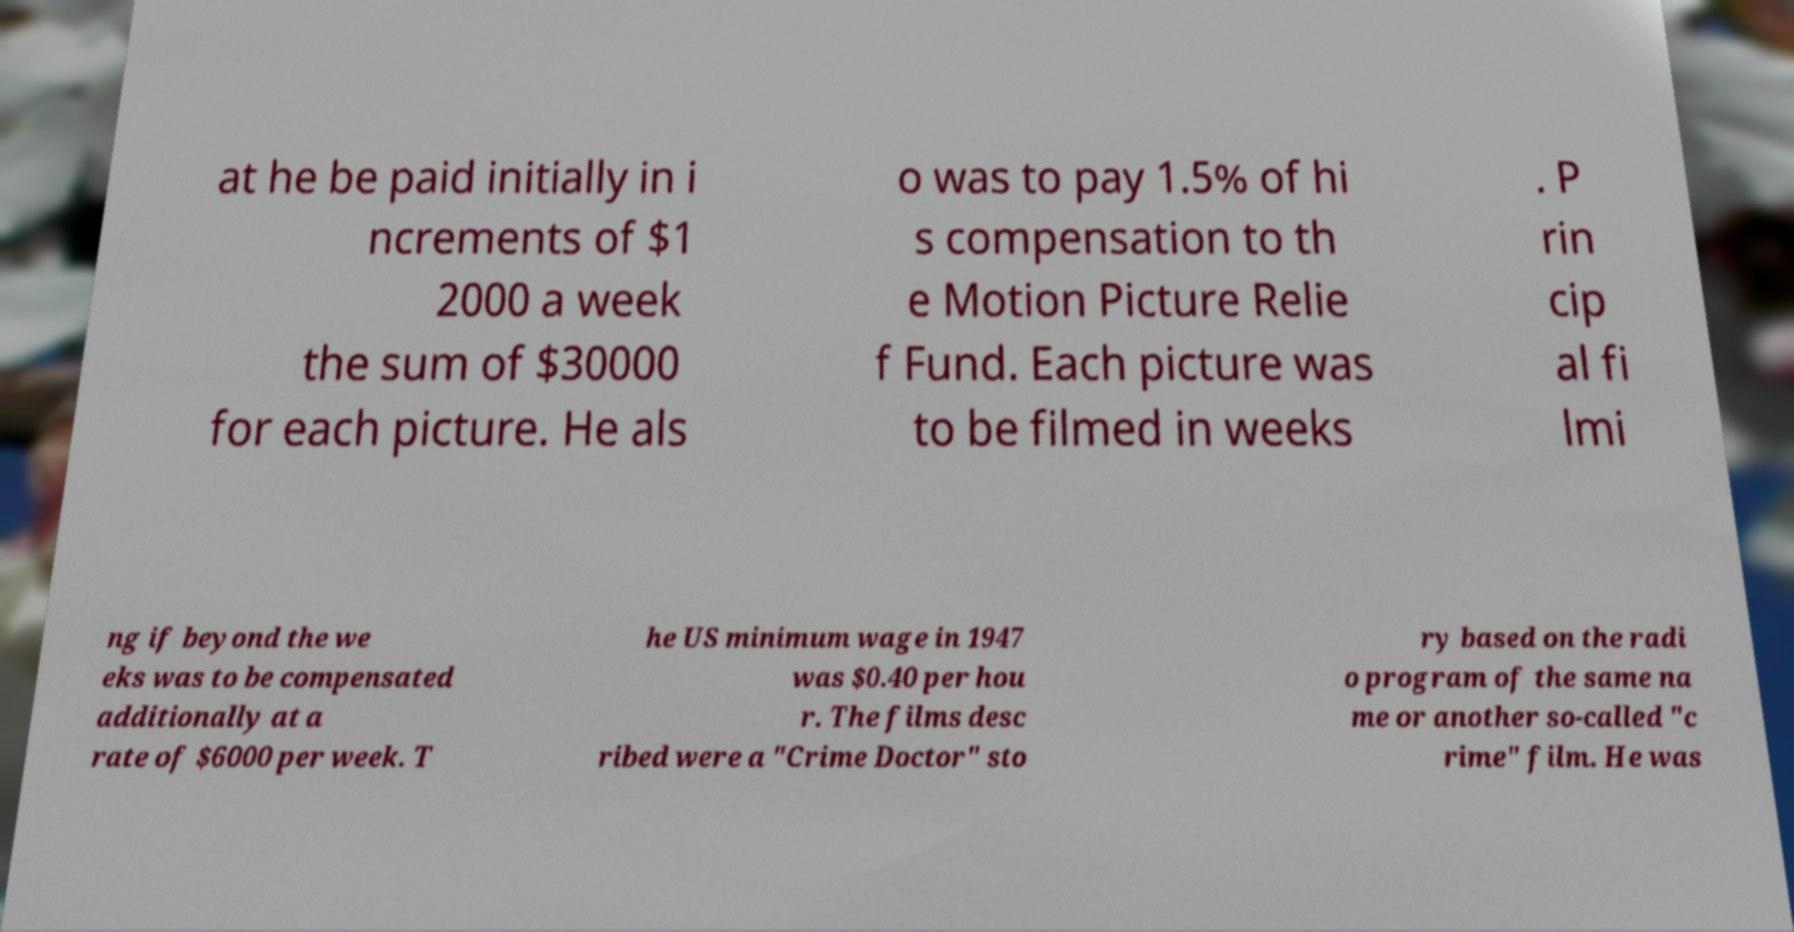For documentation purposes, I need the text within this image transcribed. Could you provide that? at he be paid initially in i ncrements of $1 2000 a week the sum of $30000 for each picture. He als o was to pay 1.5% of hi s compensation to th e Motion Picture Relie f Fund. Each picture was to be filmed in weeks . P rin cip al fi lmi ng if beyond the we eks was to be compensated additionally at a rate of $6000 per week. T he US minimum wage in 1947 was $0.40 per hou r. The films desc ribed were a "Crime Doctor" sto ry based on the radi o program of the same na me or another so-called "c rime" film. He was 